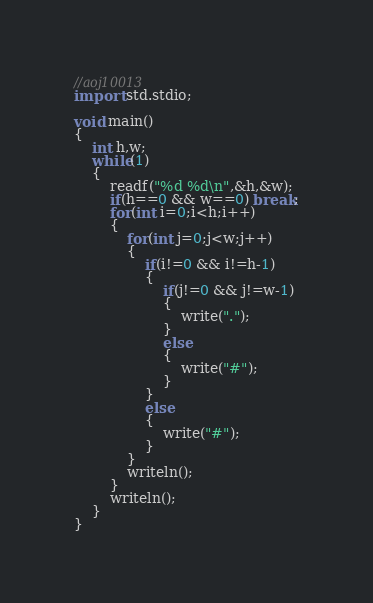<code> <loc_0><loc_0><loc_500><loc_500><_D_>//aoj10013
import std.stdio;

void main()
{
    int h,w;
    while(1)
    {
        readf("%d %d\n",&h,&w);
        if(h==0 && w==0) break;
        for(int i=0;i<h;i++)
        {
            for(int j=0;j<w;j++)
            {
                if(i!=0 && i!=h-1)
                {
                    if(j!=0 && j!=w-1)
                    {
                        write(".");
                    }
                    else
                    {
                        write("#");
                    }
                }
                else
                {
                    write("#");
                }
            }
            writeln();
        }
        writeln();
    }
}</code> 